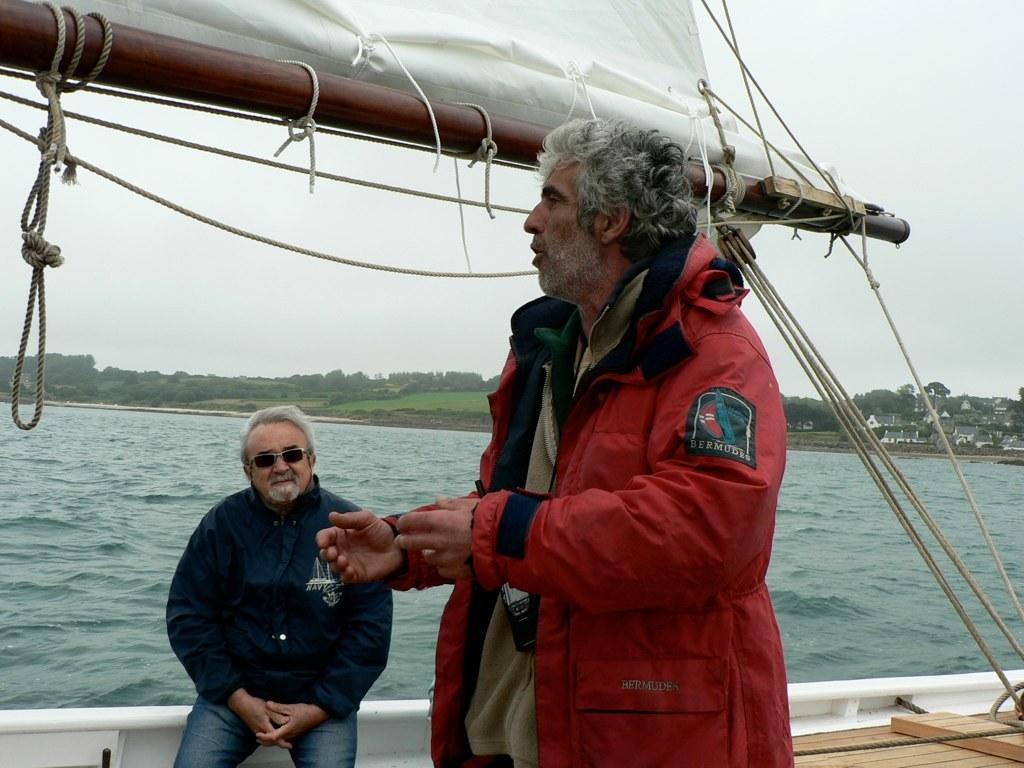Provide a one-sentence caption for the provided image. A man wearing a red jacket with a patch on the sleeve that reads Bermudes. 